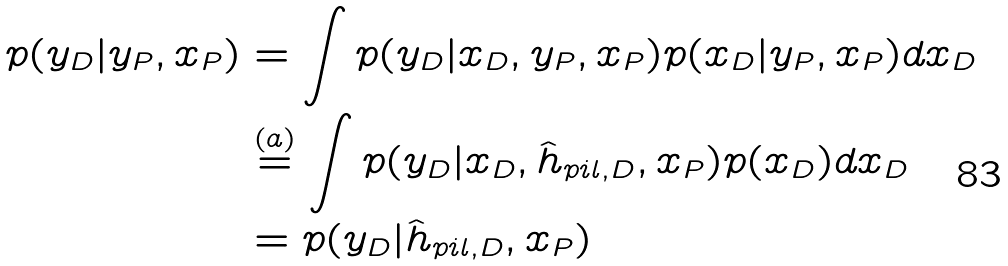Convert formula to latex. <formula><loc_0><loc_0><loc_500><loc_500>p ( y _ { D } | y _ { P } , x _ { P } ) & = \int p ( y _ { D } | x _ { D } , y _ { P } , x _ { P } ) p ( x _ { D } | y _ { P } , x _ { P } ) d x _ { D } \\ & \stackrel { ( a ) } { = } \int p ( y _ { D } | x _ { D } , \hat { h } _ { p i l , D } , x _ { P } ) p ( x _ { D } ) d x _ { D } \\ & = p ( y _ { D } | \hat { h } _ { p i l , D } , x _ { P } )</formula> 